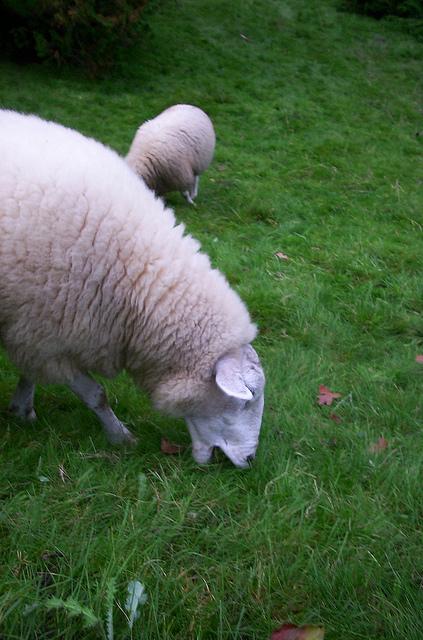What byproduct of this animal is used for clothing?
Keep it brief. Wool. What is the goat eating?
Write a very short answer. Grass. What religion used to sacrifice this animal to God?
Concise answer only. Islam. 